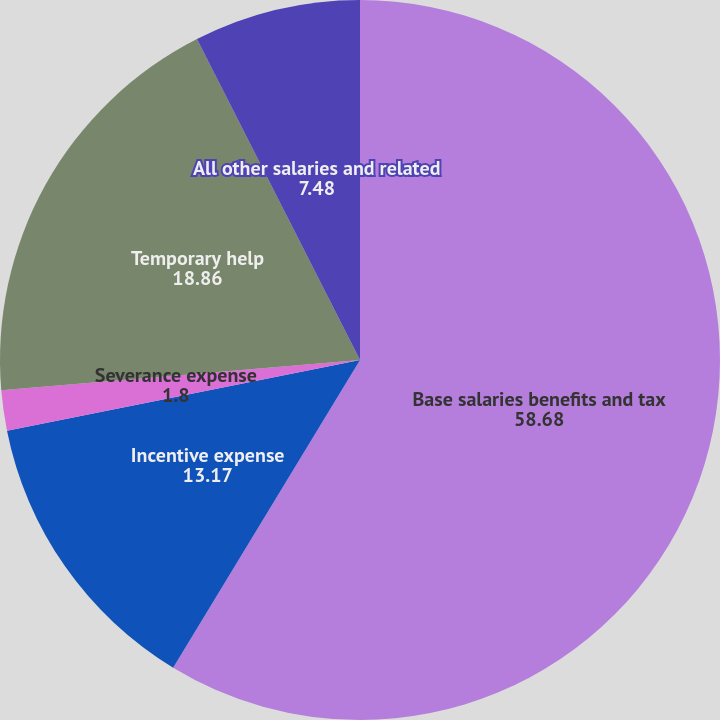<chart> <loc_0><loc_0><loc_500><loc_500><pie_chart><fcel>Base salaries benefits and tax<fcel>Incentive expense<fcel>Severance expense<fcel>Temporary help<fcel>All other salaries and related<nl><fcel>58.68%<fcel>13.17%<fcel>1.8%<fcel>18.86%<fcel>7.48%<nl></chart> 